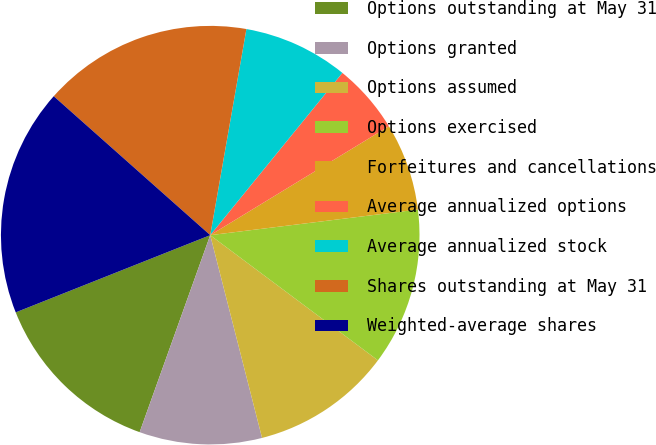<chart> <loc_0><loc_0><loc_500><loc_500><pie_chart><fcel>Options outstanding at May 31<fcel>Options granted<fcel>Options assumed<fcel>Options exercised<fcel>Forfeitures and cancellations<fcel>Average annualized options<fcel>Average annualized stock<fcel>Shares outstanding at May 31<fcel>Weighted-average shares<nl><fcel>13.51%<fcel>9.46%<fcel>10.81%<fcel>12.16%<fcel>6.76%<fcel>5.41%<fcel>8.11%<fcel>16.21%<fcel>17.57%<nl></chart> 